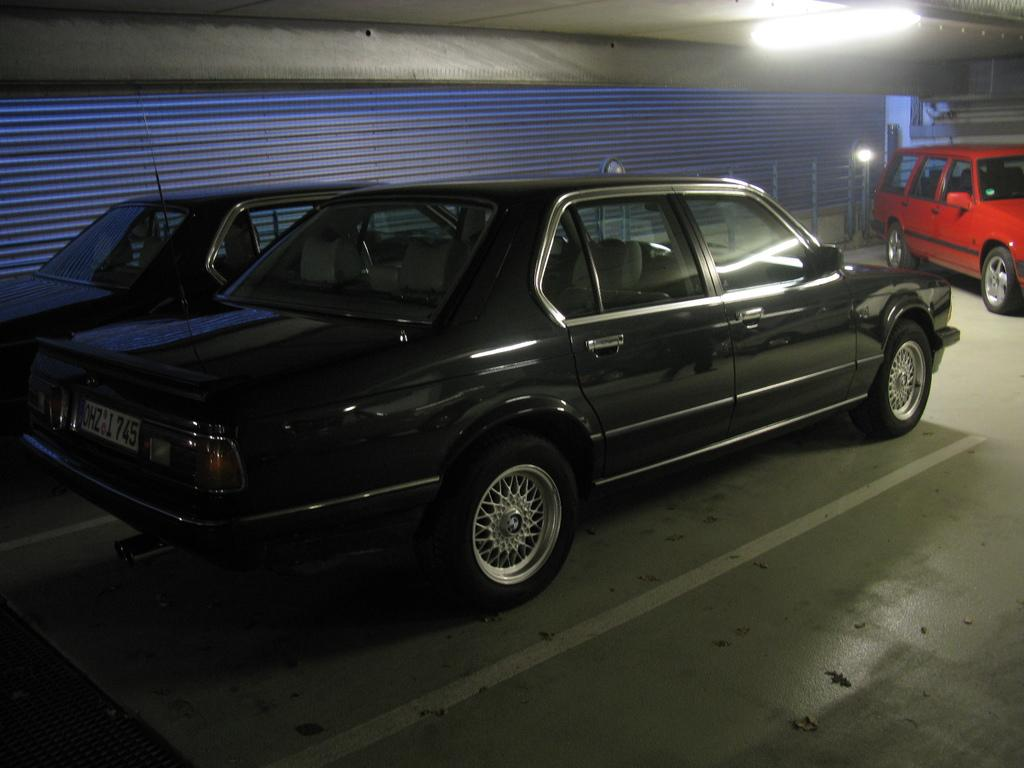What type of vehicles are present in the image? There are cars in the image. What is the background of the image? The cars are in front of a metal sheet. Can you describe the lighting in the image? There is a light in the top right of the image. What type of celery can be seen growing near the cars in the image? There is no celery present in the image; it features cars in front of a metal sheet with a light in the top right corner. 